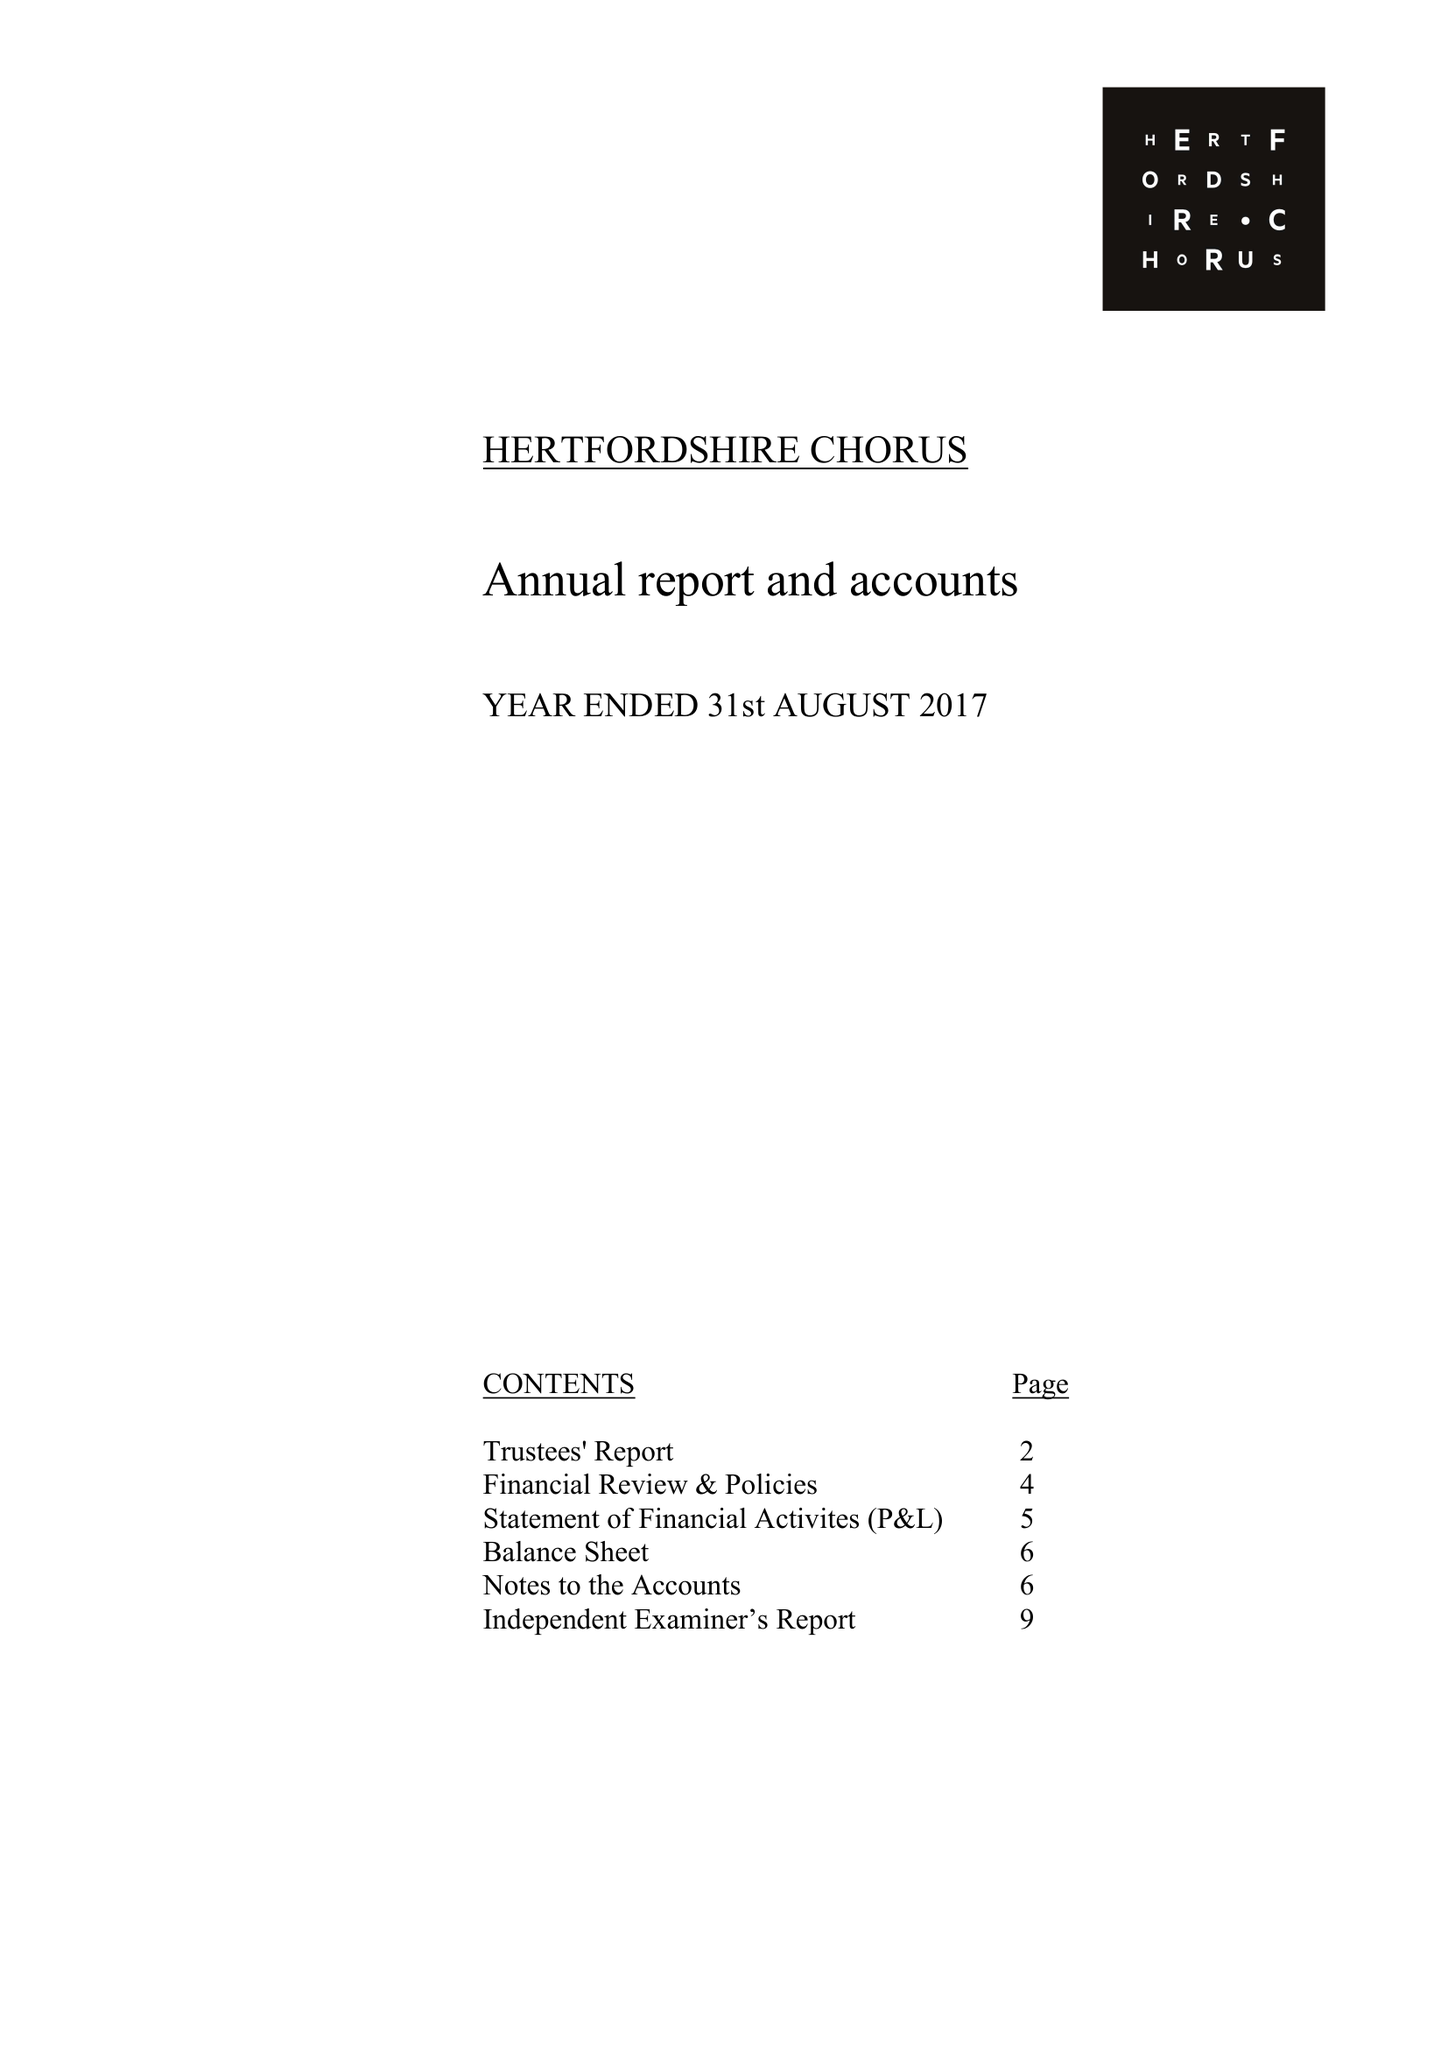What is the value for the address__post_town?
Answer the question using a single word or phrase. ST. ALBANS 